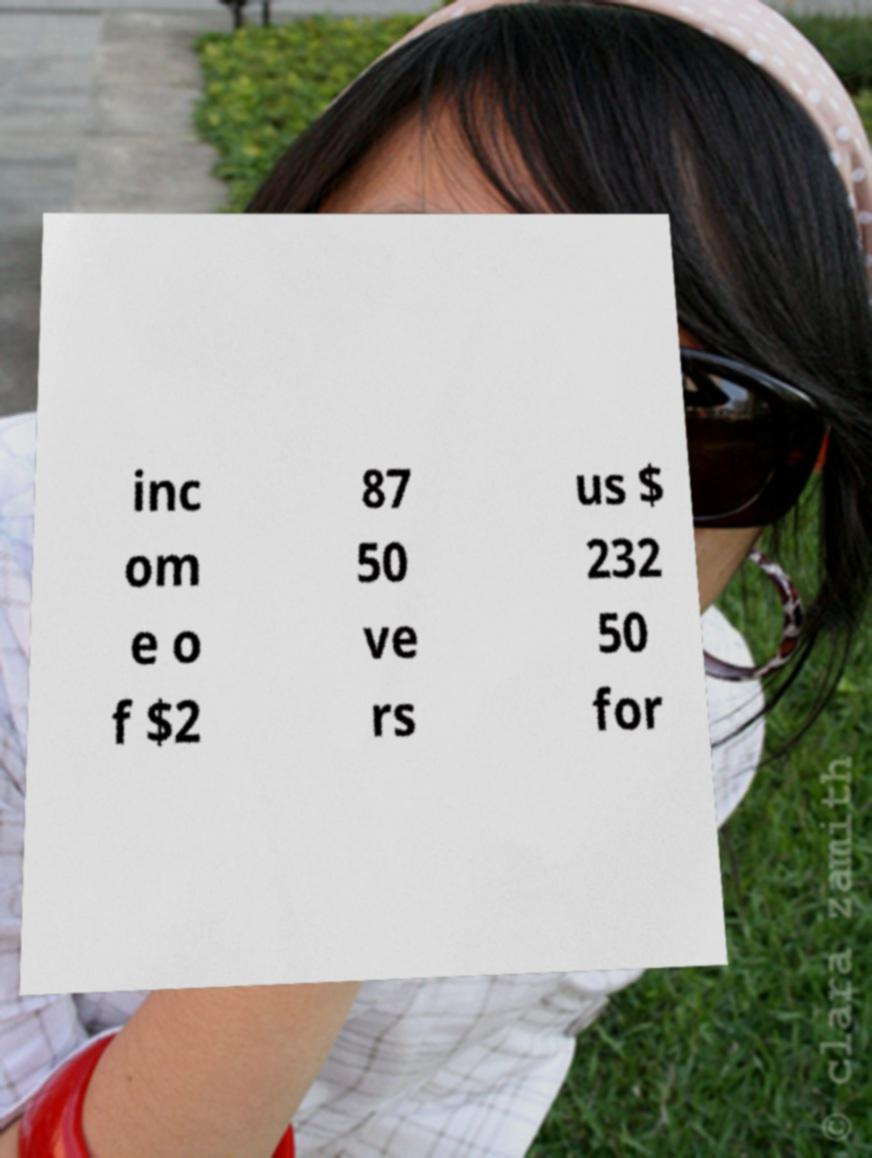Could you extract and type out the text from this image? inc om e o f $2 87 50 ve rs us $ 232 50 for 